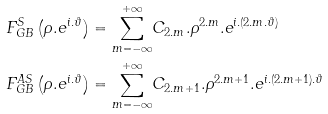<formula> <loc_0><loc_0><loc_500><loc_500>F _ { G B } ^ { S } \left ( \rho . e ^ { i . \vartheta } \right ) & = \underset { m = - \infty } { \overset { + \infty } { \sum } } C _ { 2 . m } . \rho ^ { 2 . m } . e ^ { i . ( 2 . m . \vartheta ) } \\ F _ { G B } ^ { A S } \left ( \rho . e ^ { i . \vartheta } \right ) & = \underset { m = - \infty } { \overset { + \infty } { \sum } } C _ { 2 . m + 1 } . \rho ^ { 2 . m + 1 } . e ^ { i . ( 2 . m + 1 ) . \vartheta }</formula> 